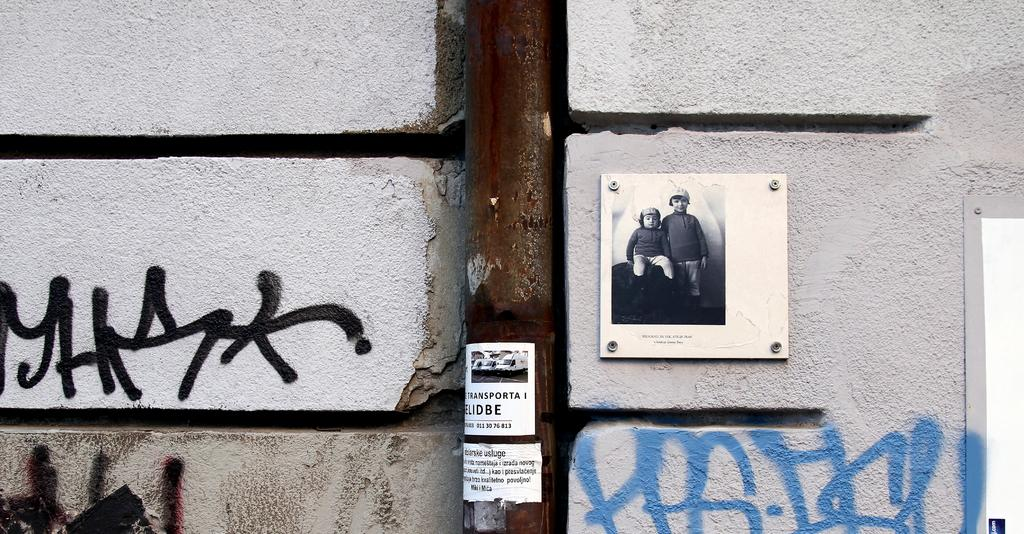What is present on the wall in the image? There is a photo on the wall in the image. Are there any other items on the wall besides the photo? Yes, there is a poster on the wall in the image. What else can be seen in the image besides the wall and its contents? There is a pole in the image. What type of veil can be seen draped over the pole in the image? There is no veil present in the image; the pole is not draped with any fabric. What is the taste of the poster in the image? The poster is not a consumable item, so it does not have a taste. 